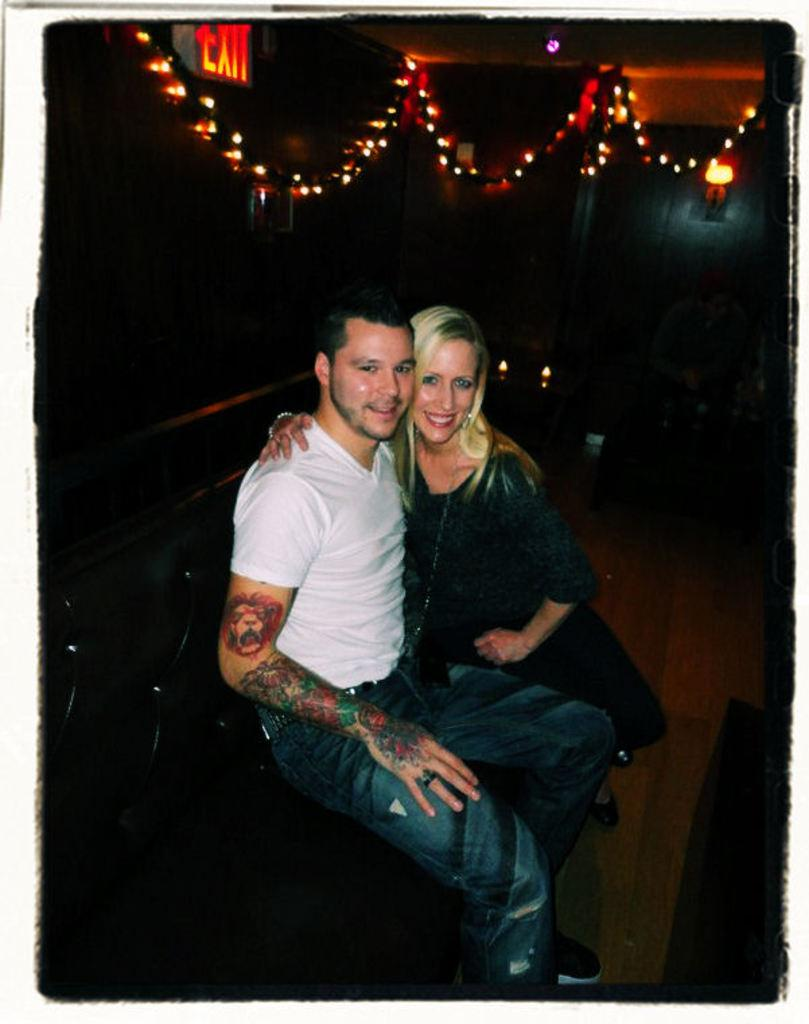Who is present in the image? There is a man and a woman in the image. What are the man and woman doing in the image? The man and woman are sitting in the image. What expressions do the man and woman have in the image? The man and woman are smiling in the image. What can be seen in the background of the image? There are lights visible in the background of the image. What type of truck can be seen on the island in the image? There is no truck or island present in the image. What is the mysterious thing that appears in the image? There is no mysterious thing present in the image; the image features a man and a woman sitting and smiling. 